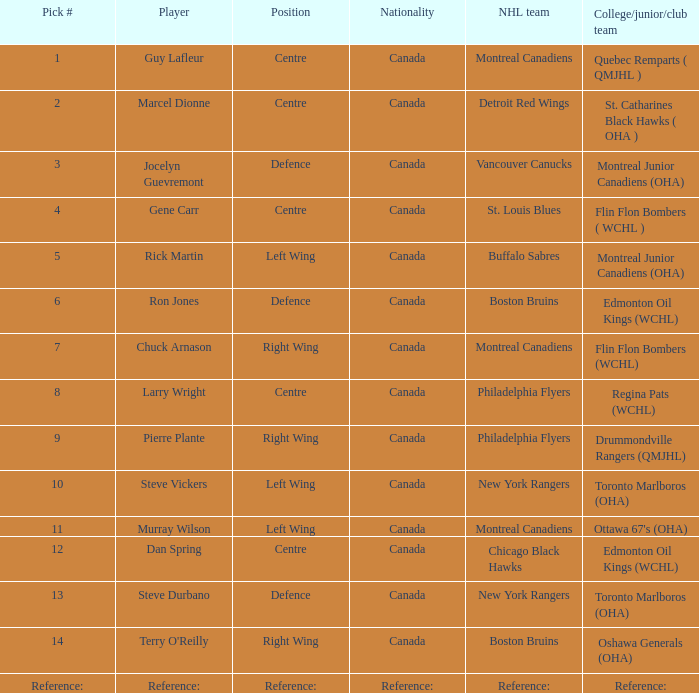Which pick number is assigned to the detroit red wings in the nhl? 2.0. 